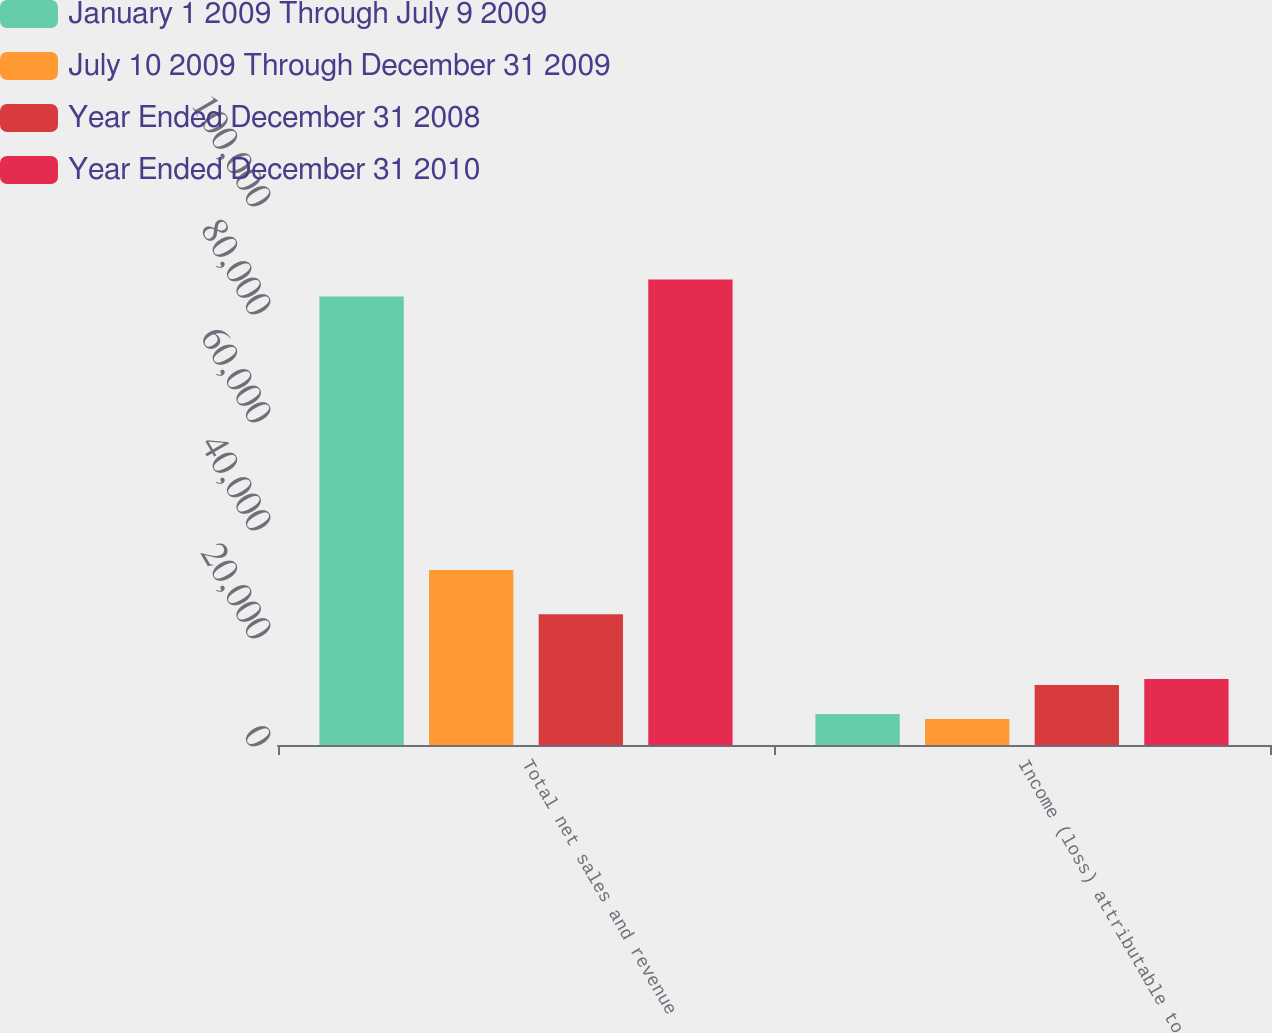Convert chart to OTSL. <chart><loc_0><loc_0><loc_500><loc_500><stacked_bar_chart><ecel><fcel>Total net sales and revenue<fcel>Income (loss) attributable to<nl><fcel>January 1 2009 Through July 9 2009<fcel>83035<fcel>5748<nl><fcel>July 10 2009 Through December 31 2009<fcel>32426<fcel>4820<nl><fcel>Year Ended December 31 2008<fcel>24191<fcel>11092<nl><fcel>Year Ended December 31 2010<fcel>86187<fcel>12203<nl></chart> 